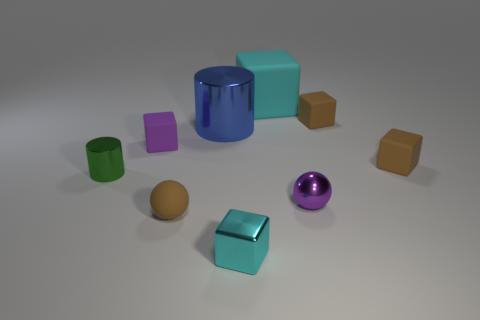Subtract all brown cubes. How many were subtracted if there are1brown cubes left? 1 Subtract all purple cubes. How many cubes are left? 4 Subtract all shiny blocks. How many blocks are left? 4 Subtract all red blocks. Subtract all purple cylinders. How many blocks are left? 5 Add 1 large matte things. How many objects exist? 10 Subtract all balls. How many objects are left? 7 Add 2 tiny brown cubes. How many tiny brown cubes exist? 4 Subtract 0 yellow blocks. How many objects are left? 9 Subtract all big cubes. Subtract all matte spheres. How many objects are left? 7 Add 9 small purple rubber things. How many small purple rubber things are left? 10 